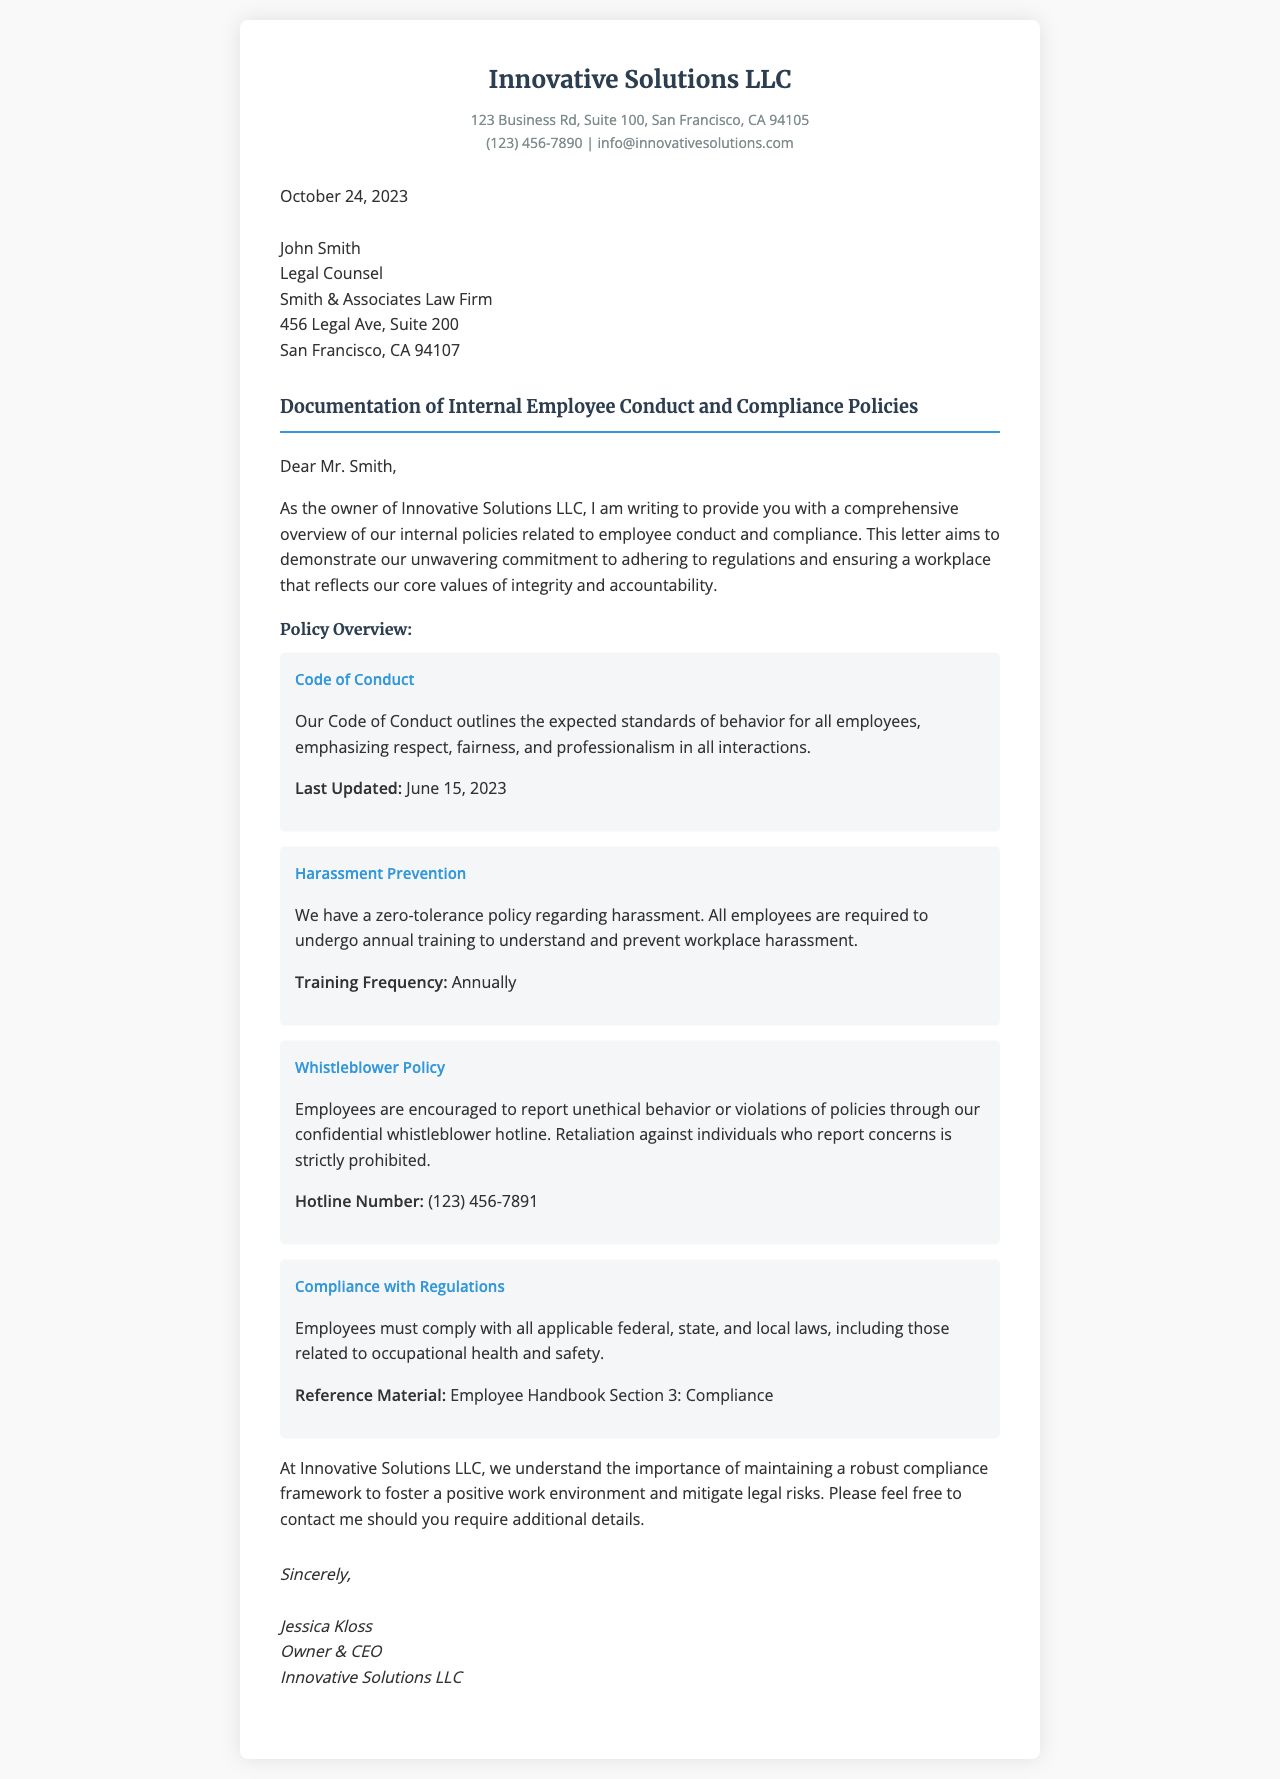What is the date of the letter? The date of the letter is stated clearly in the opening section of the correspondence.
Answer: October 24, 2023 Who is the recipient of the letter? The recipient's details are provided in the address section of the letter.
Answer: John Smith What is the subject of the letter? The subject line is clearly indicated following the recipient's details.
Answer: Documentation of Internal Employee Conduct and Compliance Policies What is the phone number for the whistleblower hotline? The whistleblower policy section includes the hotline's contact information.
Answer: (123) 456-7891 When was the Code of Conduct last updated? The policy item explains the last update date for the Code of Conduct.
Answer: June 15, 2023 Why is the harassment prevention policy important? Understanding the importance requires reasoning from the document's content regarding workplace conduct.
Answer: Zero-tolerance What is the name of the company? The company's name is prominently displayed at the top of the letter.
Answer: Innovative Solutions LLC What is the role of Jessica Kloss? Jessica Kloss's title is provided in the signature at the end of the letter.
Answer: Owner & CEO What training frequency is indicated for harassment prevention? The policy section on harassment includes details on training frequency.
Answer: Annually 